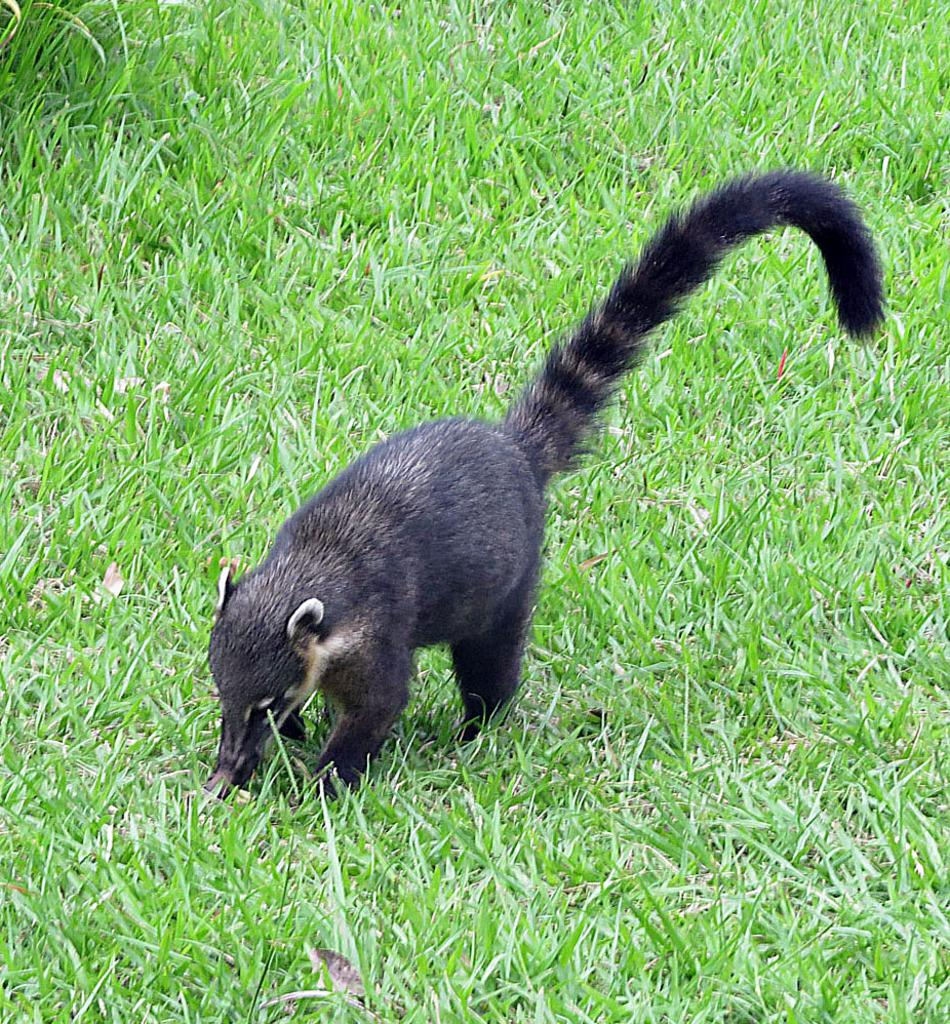What type of creature is present in the image? There is an animal in the image. How is the animal positioned in the image? The animal is standing on the ground. What type of vegetation is present on the ground in the image? There is grass on the ground in the image. How many birds are flying over the animal in the image? There are no birds present in the image. What type of ray is visible in the image? There is no ray present in the image. 